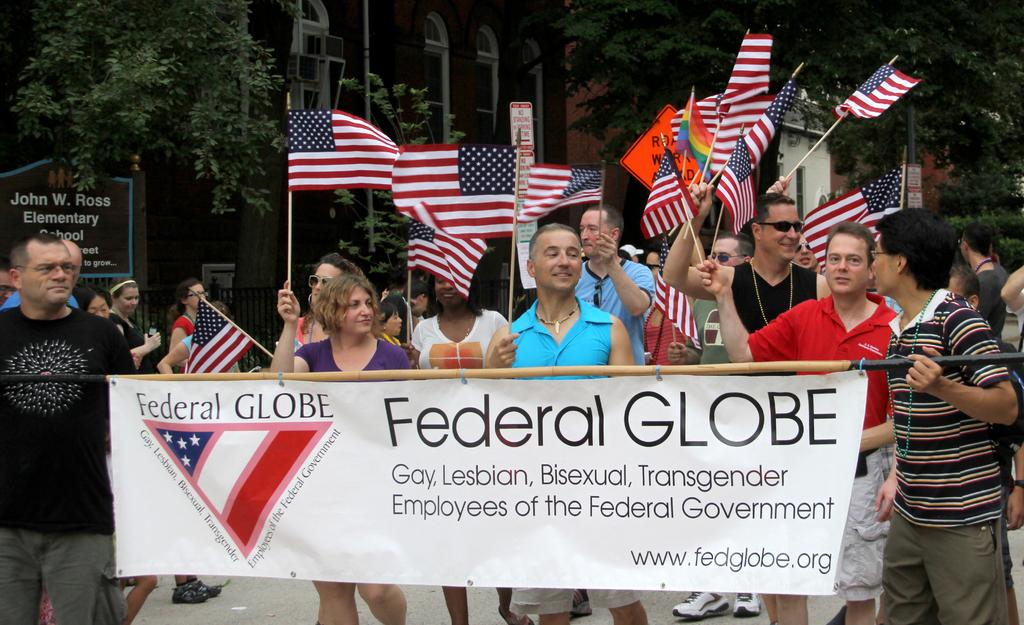What is happening in the foreground of the image? There are people in the foreground of the image. What are the people holding in their hands? The people are holding flags in their hands. What type of natural environment can be seen in the image? There are trees visible in the image. What type of man-made structures can be seen in the image? There are buildings in the image. How many chairs are visible in the image? There are no chairs visible in the image. What type of bird can be seen flying in the image? There are no birds visible in the image. 